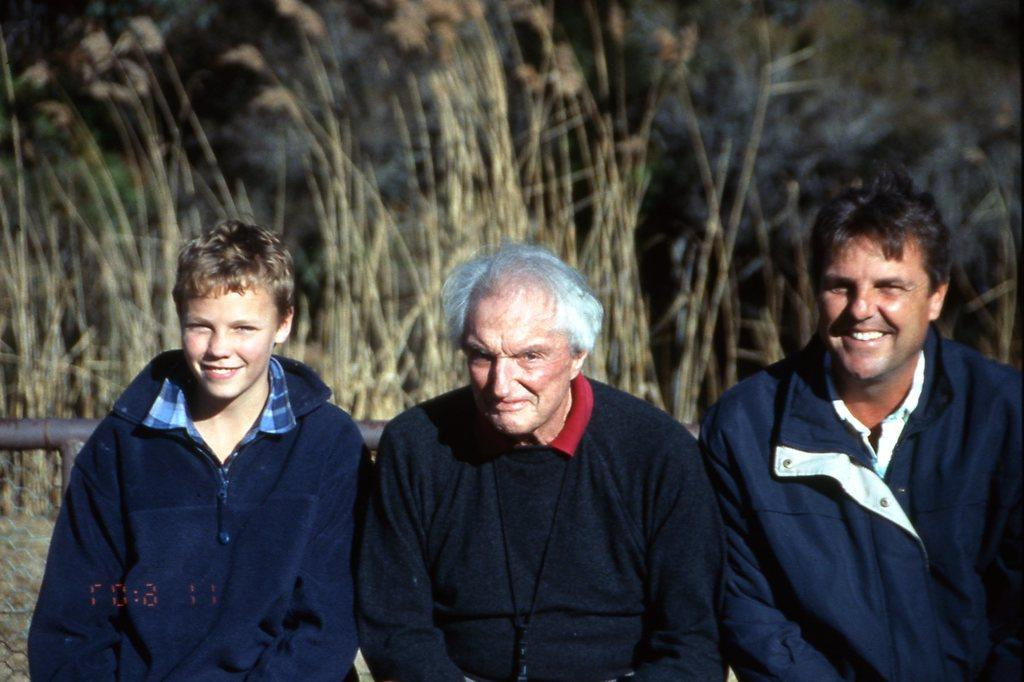How many people are in the image? There are three persons standing in the image. What can be seen in the background of the image? There is a rod and dry grass present in the background of the image. What type of poison is being used by the cats in the image? There are no cats present in the image, and therefore no poison or related activity can be observed. 